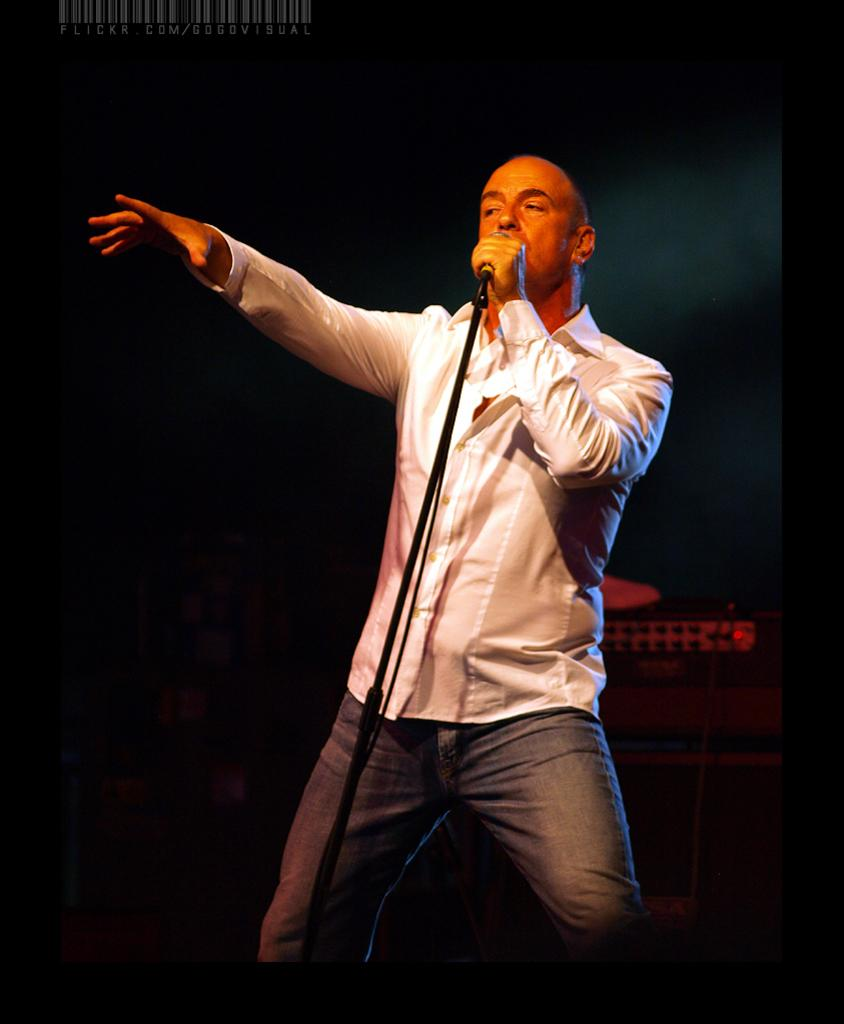What is the main subject of the image? There is a person in the image. What is the person wearing? The person is wearing a dress. What is the person holding in the image? The person is holding a microphone. How is the microphone positioned in the image? The microphone is placed on a stand. What can be seen in the background of the image? There is a device with a cable and some text visible in the background. How many bears are visible on the edge of the image? There are no bears present in the image, and the edge of the image is not mentioned in the provided facts. 